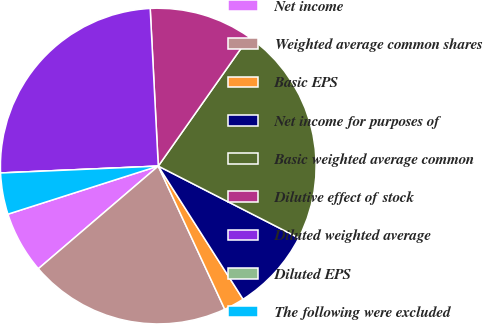<chart> <loc_0><loc_0><loc_500><loc_500><pie_chart><fcel>Net income<fcel>Weighted average common shares<fcel>Basic EPS<fcel>Net income for purposes of<fcel>Basic weighted average common<fcel>Dilutive effect of stock<fcel>Diluted weighted average<fcel>Diluted EPS<fcel>The following were excluded<nl><fcel>6.34%<fcel>20.65%<fcel>2.11%<fcel>8.45%<fcel>22.77%<fcel>10.57%<fcel>24.88%<fcel>0.0%<fcel>4.23%<nl></chart> 